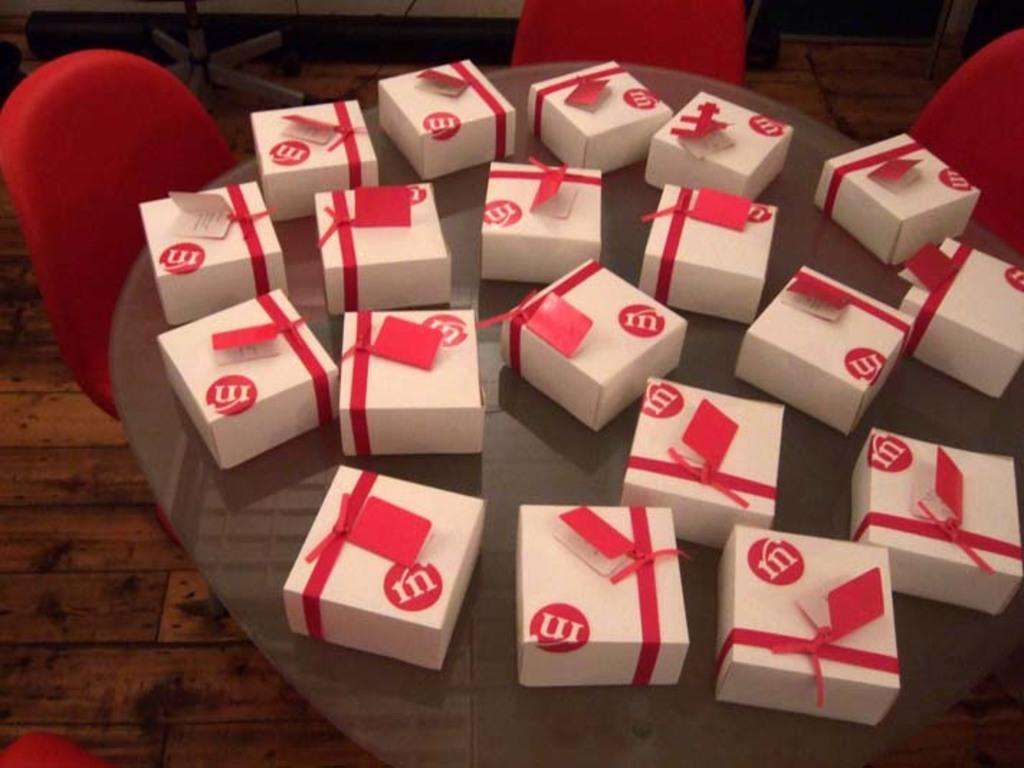<image>
Create a compact narrative representing the image presented. White boxes with red accents including a white M is a red circle sit on a table. 